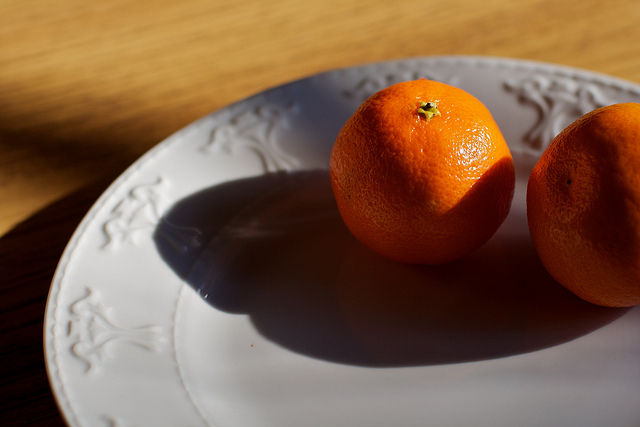Imagine a very creative scenario starting with these oranges. As the morning sun warms the two oranges on the elegant plate, they suddenly begin to glow softly. Enchanted, they roll off the plate and embark on a magical journey across the kitchen. Their vibrant glow attracts other fruits, vegetables, and even kitchen utensils, which join them in a whimsical parade. Together, they march through the house, bringing a touch of magic to everything they pass. By evening, the oranges have led their newfound friends to a secret garden hidden within the house, where they transform the mundane into a fantastical feast of lights, colors, and laughter. 